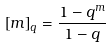<formula> <loc_0><loc_0><loc_500><loc_500>\left [ m \right ] _ { q } = \frac { 1 - q ^ { m } } { 1 - q }</formula> 